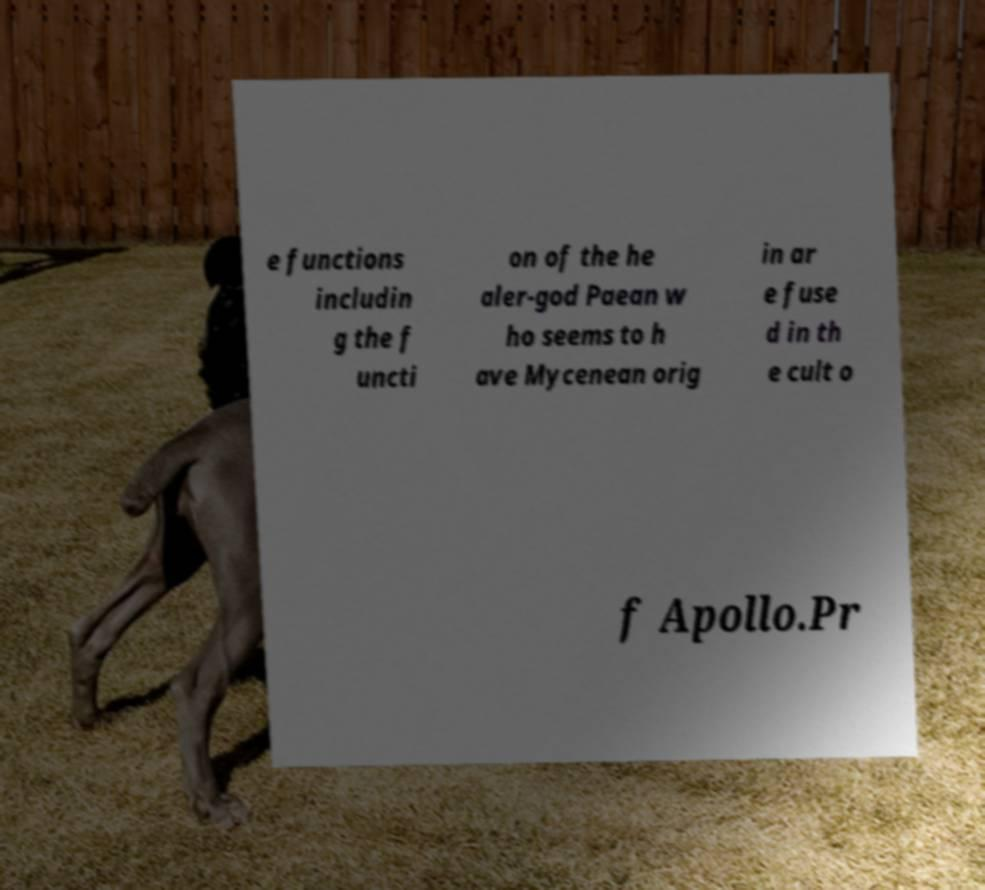There's text embedded in this image that I need extracted. Can you transcribe it verbatim? e functions includin g the f uncti on of the he aler-god Paean w ho seems to h ave Mycenean orig in ar e fuse d in th e cult o f Apollo.Pr 